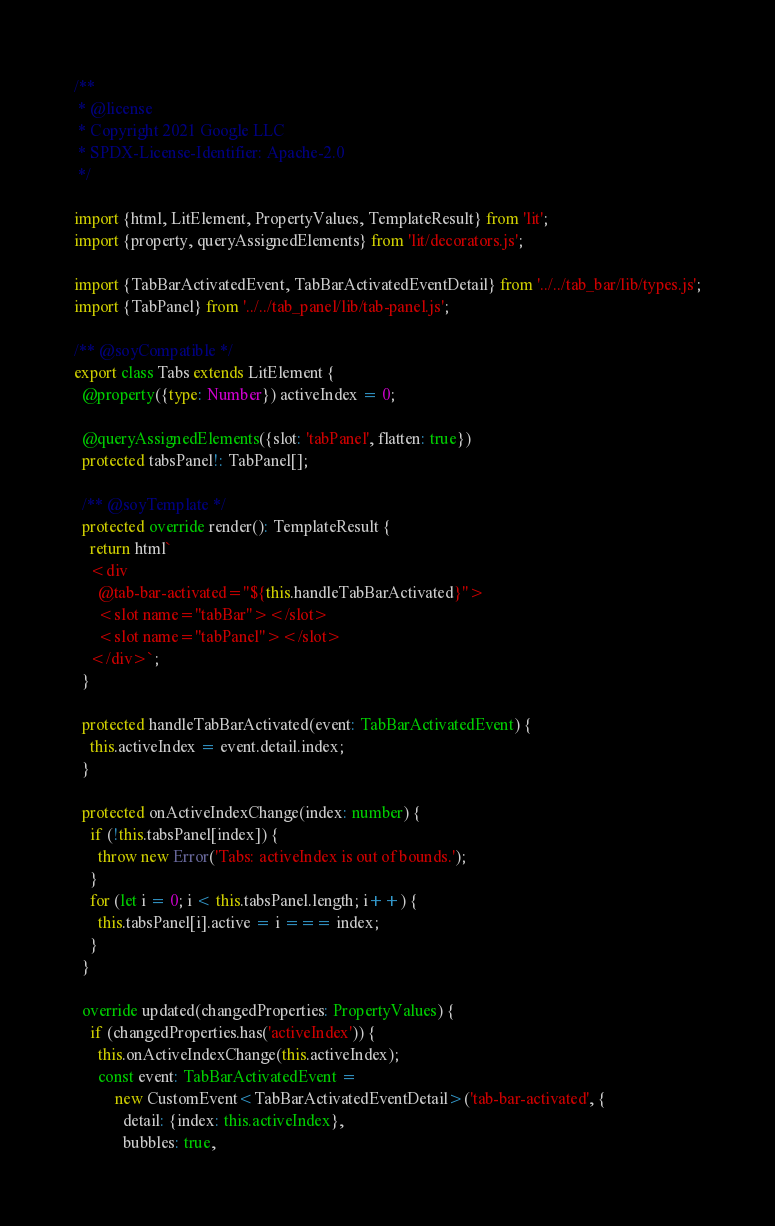Convert code to text. <code><loc_0><loc_0><loc_500><loc_500><_TypeScript_>/**
 * @license
 * Copyright 2021 Google LLC
 * SPDX-License-Identifier: Apache-2.0
 */

import {html, LitElement, PropertyValues, TemplateResult} from 'lit';
import {property, queryAssignedElements} from 'lit/decorators.js';

import {TabBarActivatedEvent, TabBarActivatedEventDetail} from '../../tab_bar/lib/types.js';
import {TabPanel} from '../../tab_panel/lib/tab-panel.js';

/** @soyCompatible */
export class Tabs extends LitElement {
  @property({type: Number}) activeIndex = 0;

  @queryAssignedElements({slot: 'tabPanel', flatten: true})
  protected tabsPanel!: TabPanel[];

  /** @soyTemplate */
  protected override render(): TemplateResult {
    return html`
    <div
      @tab-bar-activated="${this.handleTabBarActivated}">
      <slot name="tabBar"></slot>
      <slot name="tabPanel"></slot>
    </div>`;
  }

  protected handleTabBarActivated(event: TabBarActivatedEvent) {
    this.activeIndex = event.detail.index;
  }

  protected onActiveIndexChange(index: number) {
    if (!this.tabsPanel[index]) {
      throw new Error('Tabs: activeIndex is out of bounds.');
    }
    for (let i = 0; i < this.tabsPanel.length; i++) {
      this.tabsPanel[i].active = i === index;
    }
  }

  override updated(changedProperties: PropertyValues) {
    if (changedProperties.has('activeIndex')) {
      this.onActiveIndexChange(this.activeIndex);
      const event: TabBarActivatedEvent =
          new CustomEvent<TabBarActivatedEventDetail>('tab-bar-activated', {
            detail: {index: this.activeIndex},
            bubbles: true,</code> 